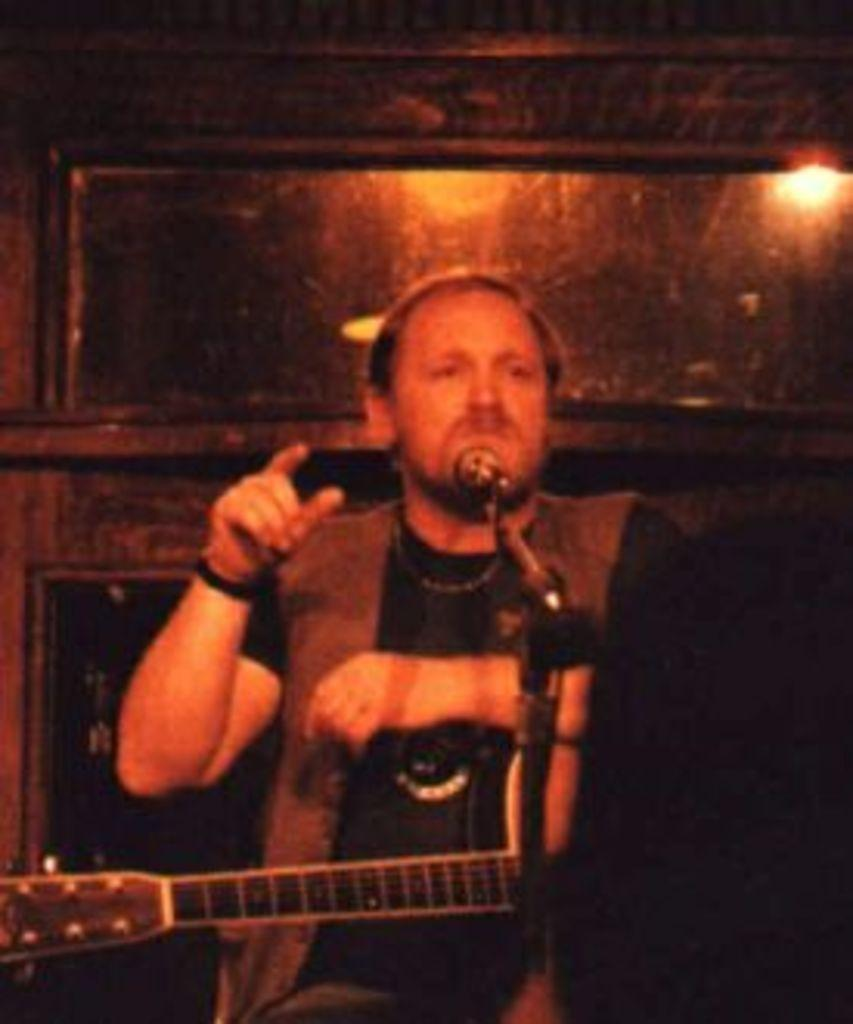Who is the main subject in the image? There is a man in the center of the image. What is the man doing in the image? The man is standing and holding a guitar. What equipment is set up for the man in the image? There is a microphone placed on a stand before the man. What can be seen in the background of the image? There is a wall and a light visible in the background. What is the chance of rain in the image? There is no mention of rain or any weather condition in the image. --- Facts: 1. There is a group of people in the image. 2. The people are wearing costumes. 3. The costumes are related to a specific theme. 4. There are decorations related to the theme. 5. The background is dark. Absurd Topics: dinosaur, ocean, submarine Conversation: How many people are in the image? There is a group of people in the image. What are the people wearing in the image? The people are wearing costumes. What theme are the costumes and decorations related to? The costumes are related to a specific theme, and there are decorations related to the theme. What can be seen in the background of the image? The background is dark. Reasoning: Let's think step by step in order to produce the conversation. We start by identifying the main subject of the image, which is the group of people. Then, we describe what the people are wearing, mentioning the theme related to the costumes and decorations. Finally, we describe the background of the image. Each question is designed to elicit a specific detail about the image that is known from the provided facts. Absurd Question/Answer: Can you see a dinosaur in the image? There is no dinosaur present in the image. --- Facts: 1. There is a dog in the image. 2. The dog is sitting on a chair. 3. The dog is wearing a hat. 4. There is a bowl of food in front of the dog. 5. The background is a living room. Absurd Topics: spaceship, alien, galaxy Conversation: What type of animal is in the image? There is a dog in the image. What is the dog doing in the image? The dog is sitting on a chair. What is the dog wearing in the image? The dog is wearing a hat. What is in front of the dog in the image? There is a bowl of food in front of the dog. What can be seen in the background of the image? The background is a living room. Reasoning: Let's think step by step in order to produce the conversation. We start by identifying the main subject of the image, which is the dog. Then, we describe what the dog is doing, mentioning the hat the dog is 